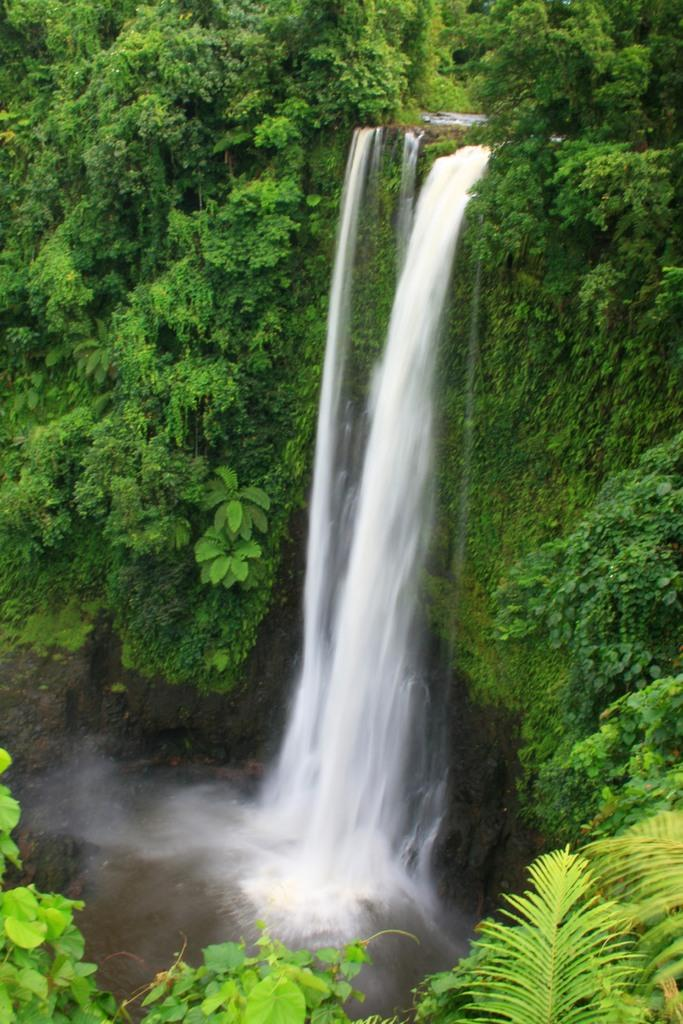What natural feature is the main subject of the image? There is a waterfall in the image. What type of vegetation is present around the waterfall? There are plants and trees around the waterfall. What type of butter can be seen melting on the guitar in the image? There is no guitar or butter present in the image; it features a waterfall surrounded by plants and trees. 